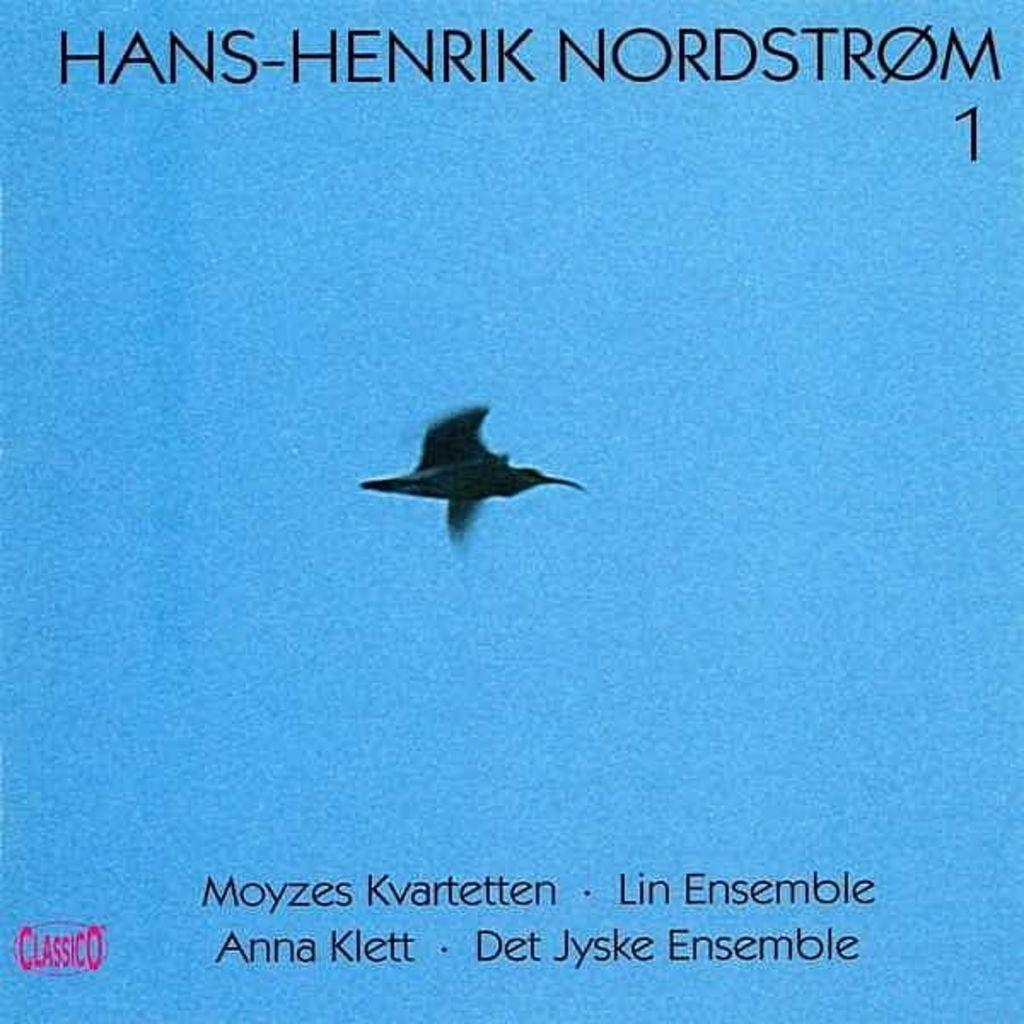What type of visual medium is the image? The image is a poster. What is happening in the poster? There is a bird flying in the poster. What else can be found on the poster besides the bird? There is text on the poster. Can you see any giants walking along the river in the image? There are no giants or rivers present in the image; it features a bird flying in a poster with text. 